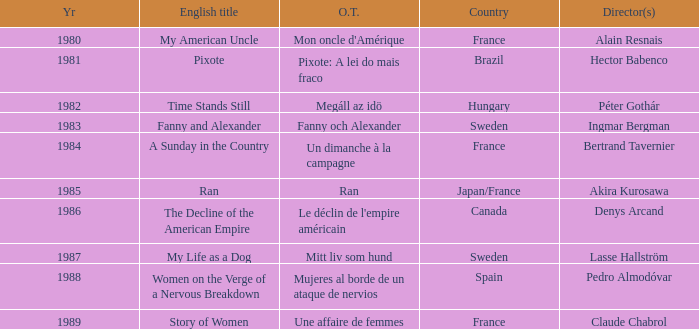What's the English Title of Fanny Och Alexander? Fanny and Alexander. 